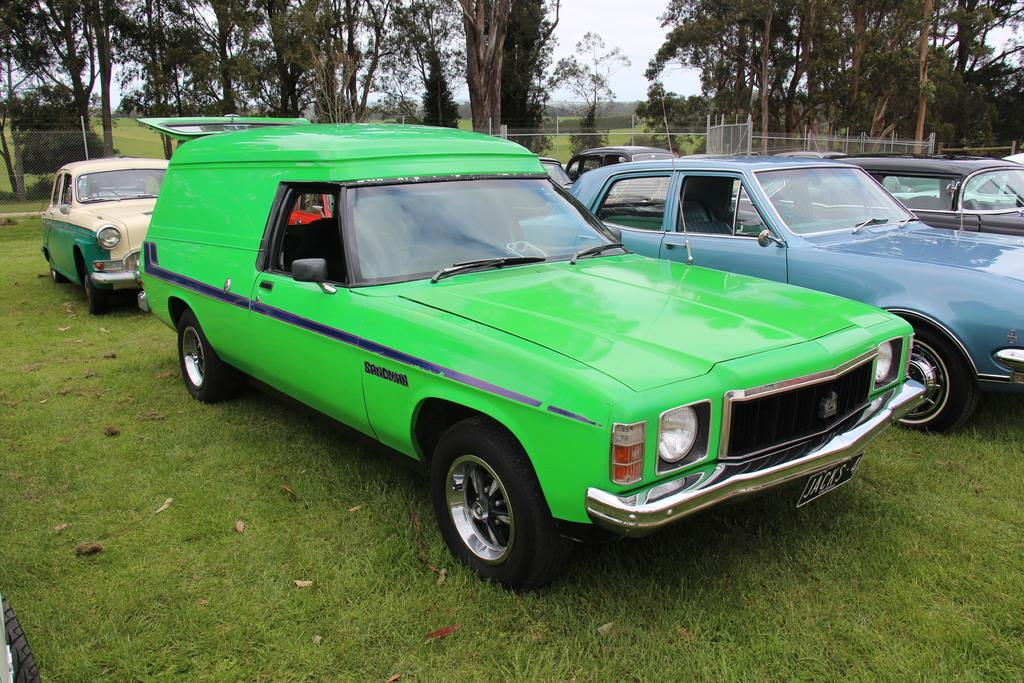What type of vehicles are on the ground in the image? There are cars on the ground in the image. What can be seen in the background of the image? There is a fence, trees, and the sky visible in the background of the image. What type of shock can be seen affecting the cars in the image? There is no shock affecting the cars in the image; they appear to be stationary on the ground. 